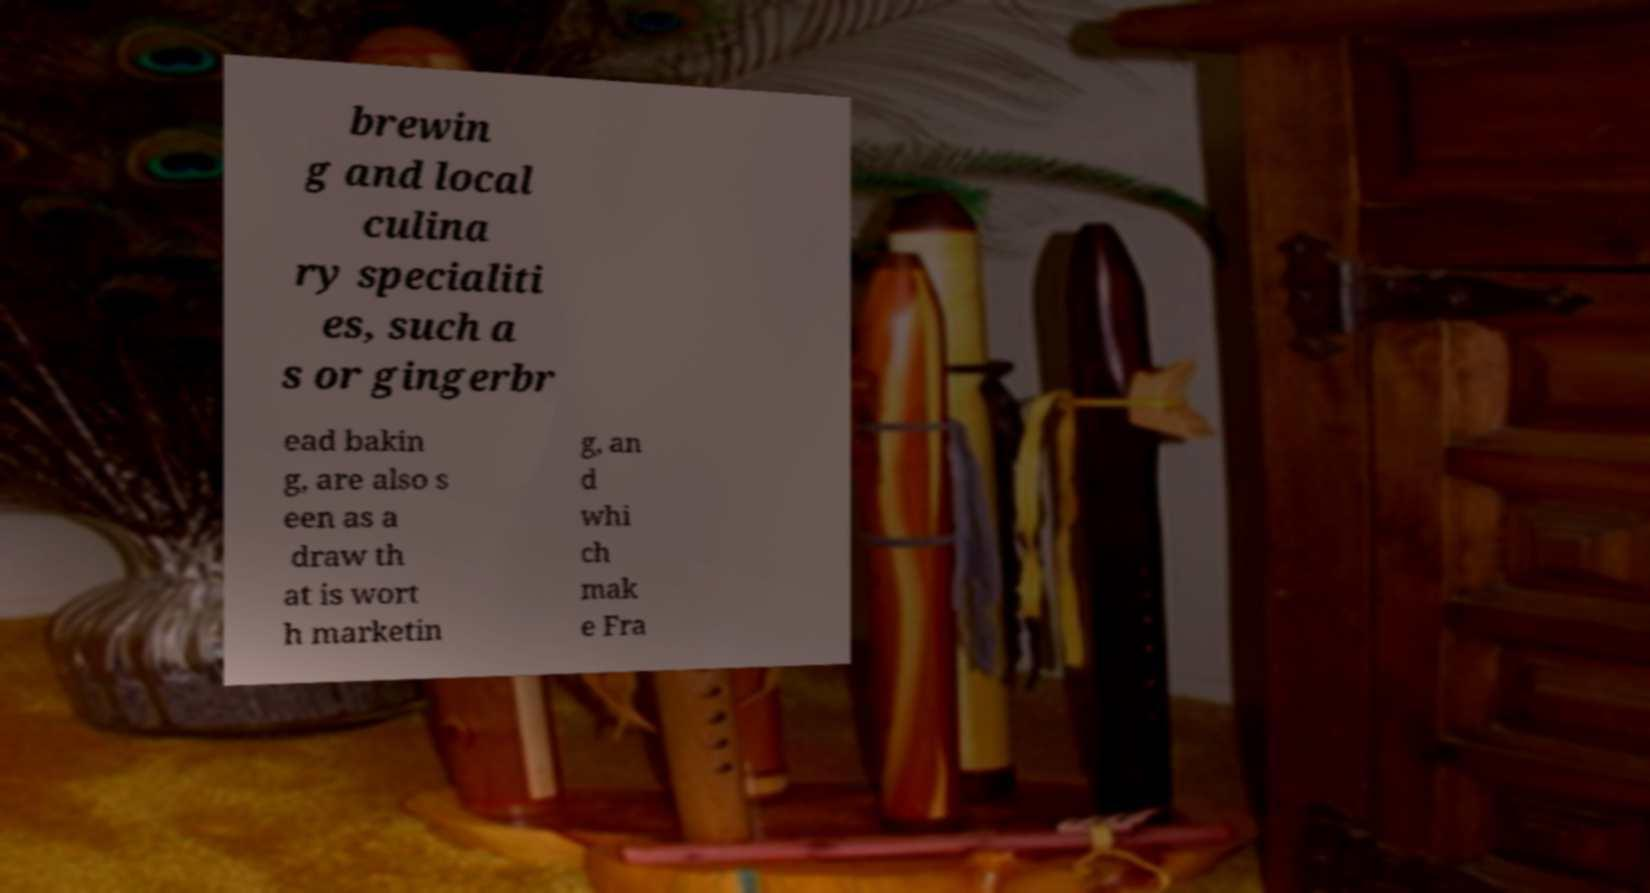Can you accurately transcribe the text from the provided image for me? brewin g and local culina ry specialiti es, such a s or gingerbr ead bakin g, are also s een as a draw th at is wort h marketin g, an d whi ch mak e Fra 